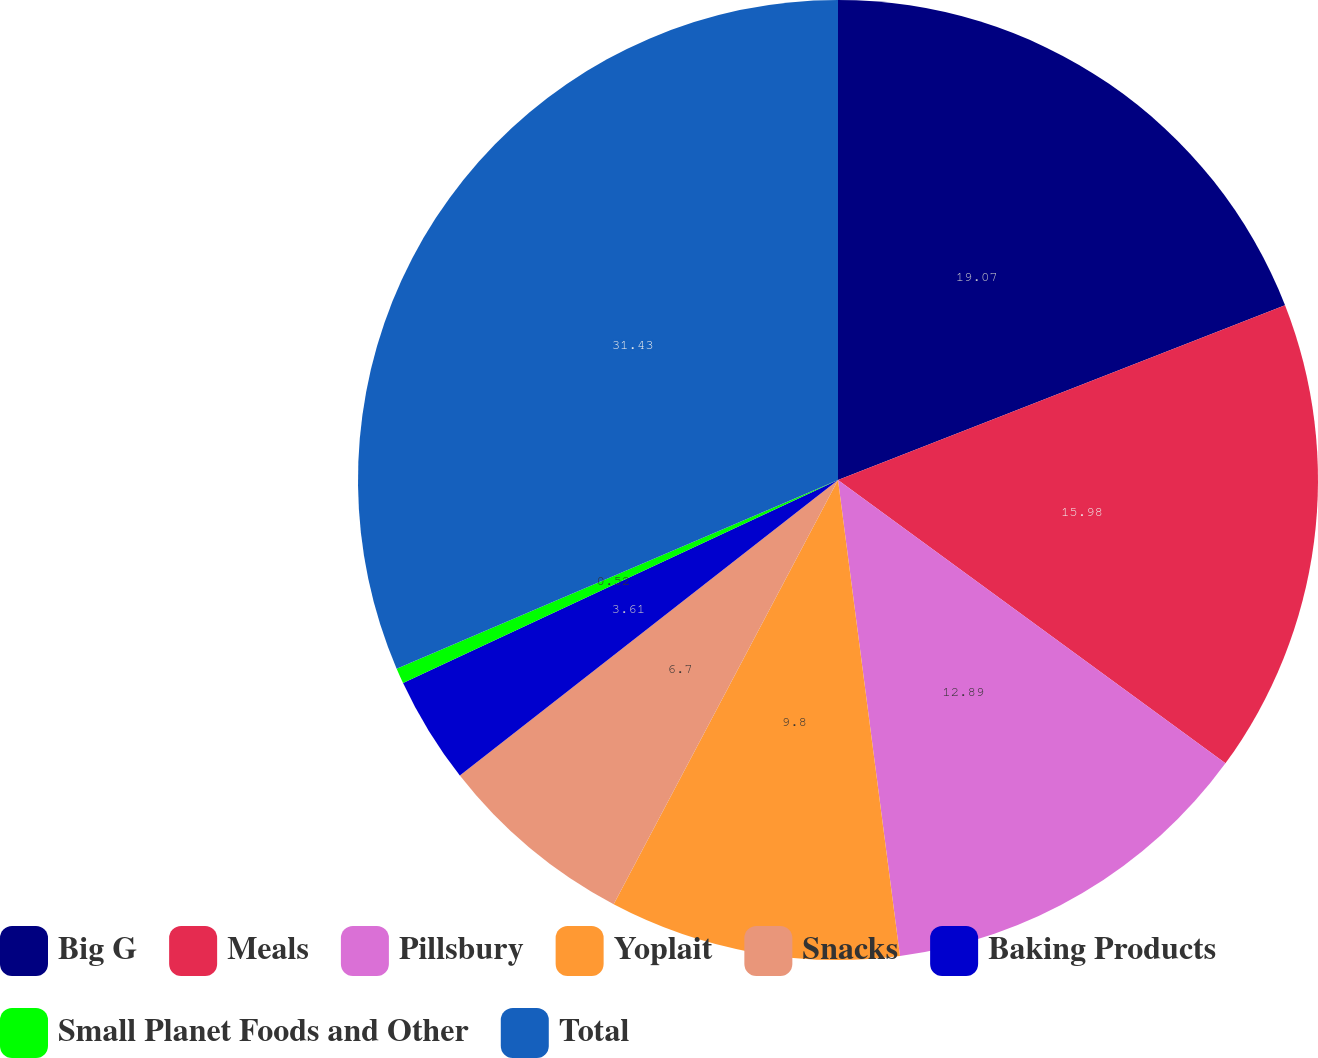<chart> <loc_0><loc_0><loc_500><loc_500><pie_chart><fcel>Big G<fcel>Meals<fcel>Pillsbury<fcel>Yoplait<fcel>Snacks<fcel>Baking Products<fcel>Small Planet Foods and Other<fcel>Total<nl><fcel>19.07%<fcel>15.98%<fcel>12.89%<fcel>9.8%<fcel>6.7%<fcel>3.61%<fcel>0.52%<fcel>31.43%<nl></chart> 